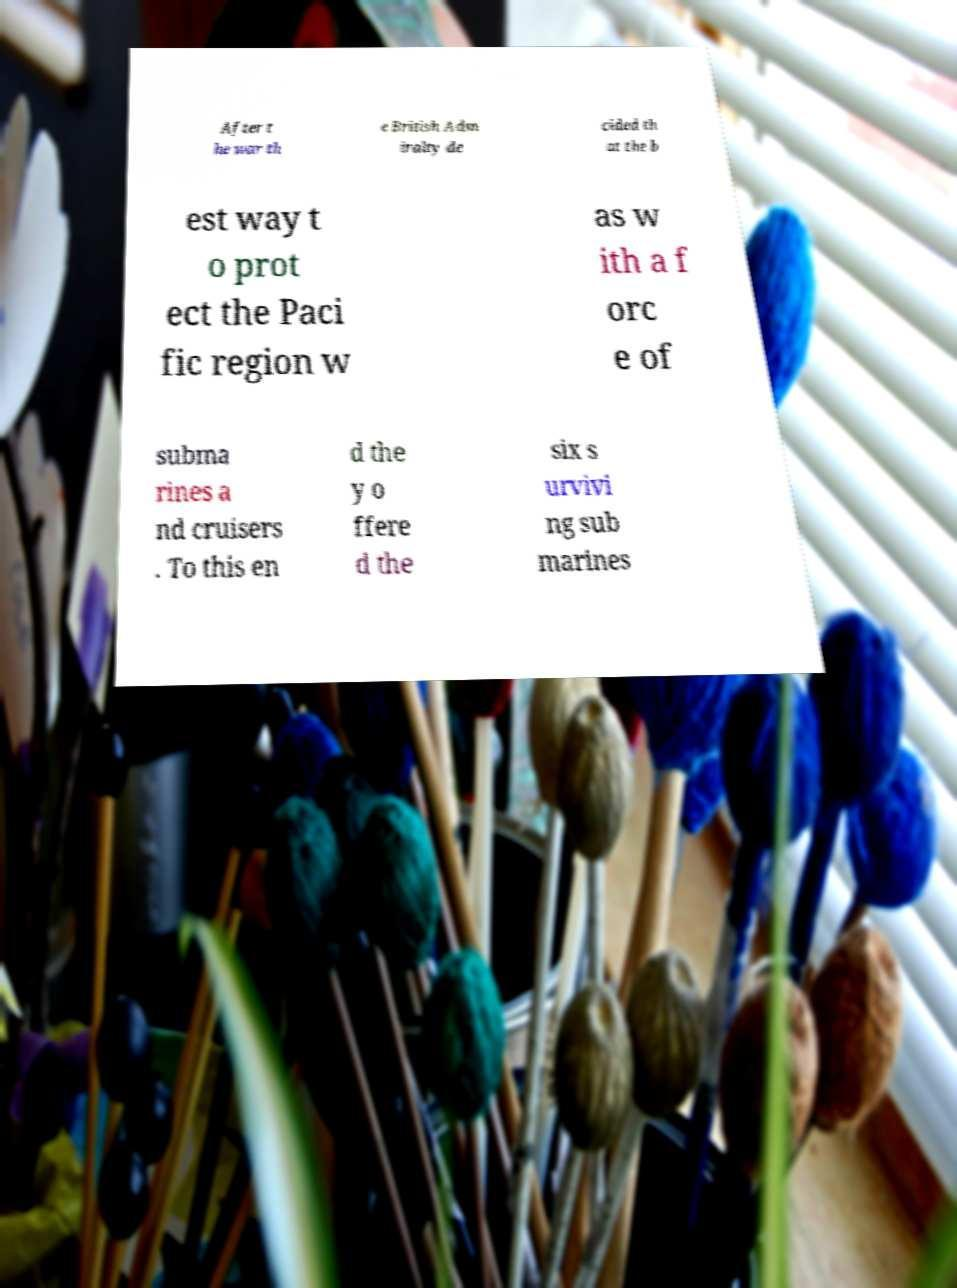What messages or text are displayed in this image? I need them in a readable, typed format. After t he war th e British Adm iralty de cided th at the b est way t o prot ect the Paci fic region w as w ith a f orc e of subma rines a nd cruisers . To this en d the y o ffere d the six s urvivi ng sub marines 